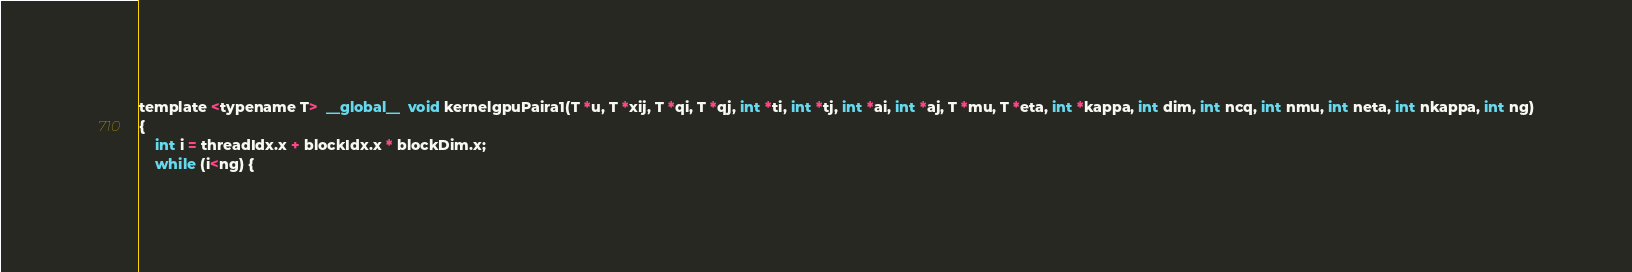<code> <loc_0><loc_0><loc_500><loc_500><_Cuda_>template <typename T>  __global__  void kernelgpuPaira1(T *u, T *xij, T *qi, T *qj, int *ti, int *tj, int *ai, int *aj, T *mu, T *eta, int *kappa, int dim, int ncq, int nmu, int neta, int nkappa, int ng)
{
	int i = threadIdx.x + blockIdx.x * blockDim.x;
	while (i<ng) {</code> 